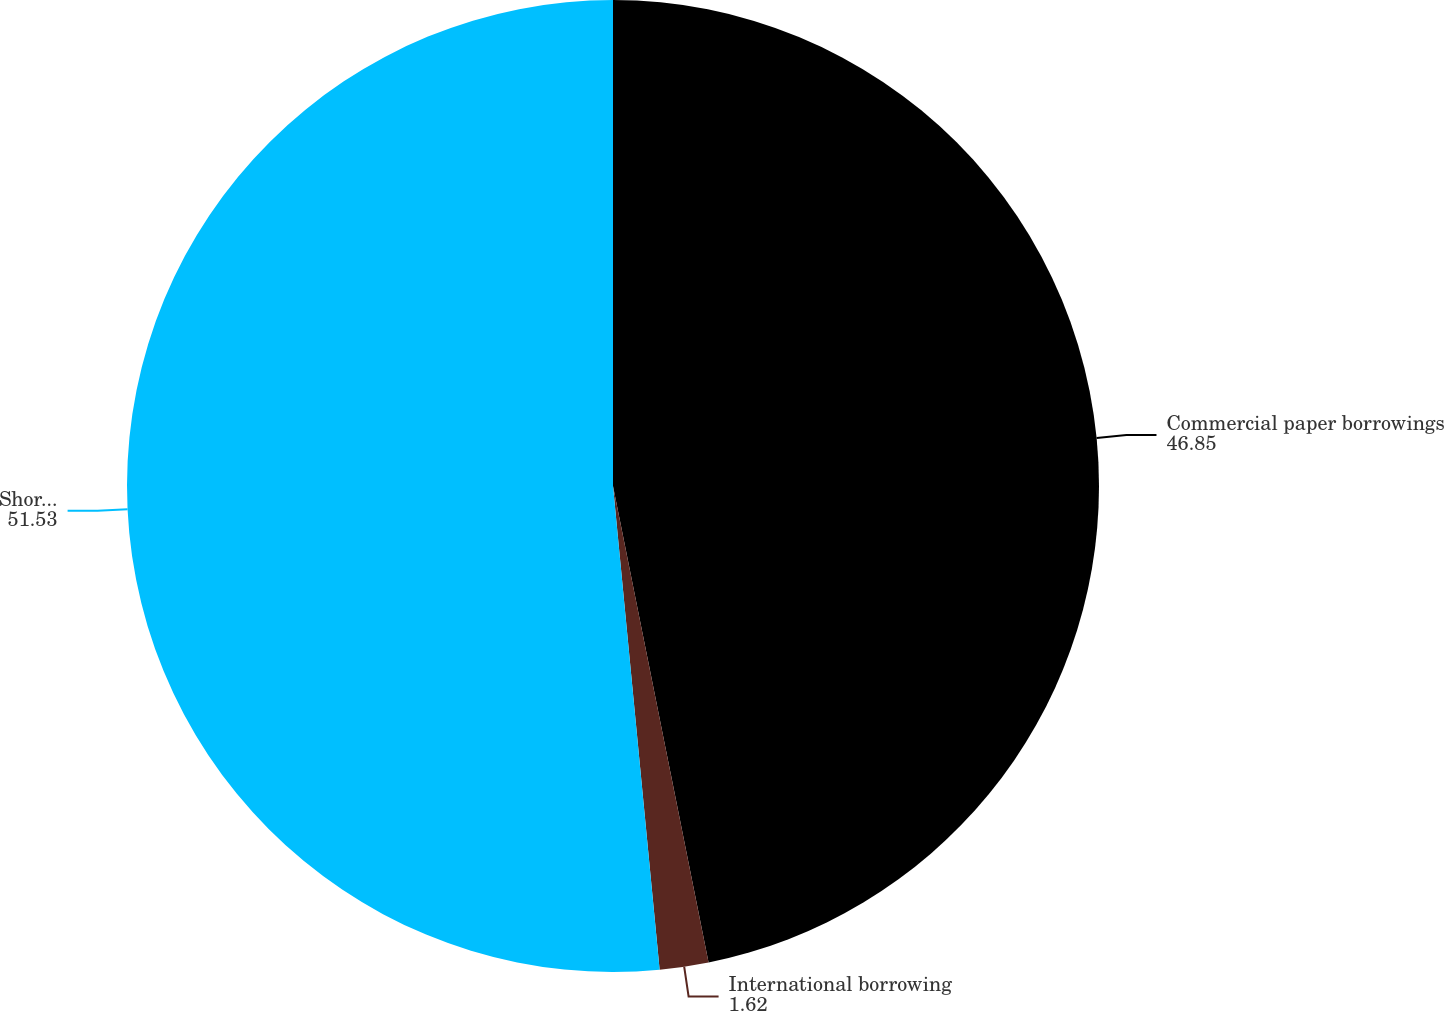Convert chart to OTSL. <chart><loc_0><loc_0><loc_500><loc_500><pie_chart><fcel>Commercial paper borrowings<fcel>International borrowing<fcel>Short-term borrowings<nl><fcel>46.85%<fcel>1.62%<fcel>51.53%<nl></chart> 